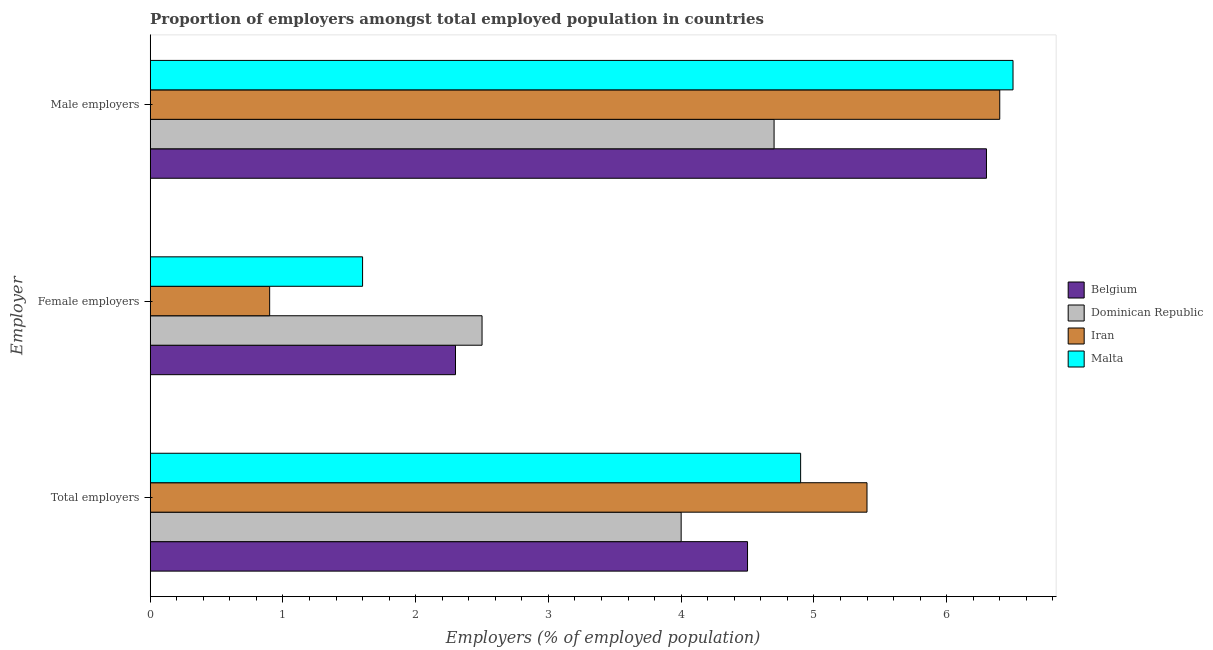How many different coloured bars are there?
Make the answer very short. 4. Are the number of bars on each tick of the Y-axis equal?
Offer a very short reply. Yes. How many bars are there on the 3rd tick from the top?
Offer a terse response. 4. What is the label of the 2nd group of bars from the top?
Keep it short and to the point. Female employers. What is the percentage of total employers in Belgium?
Provide a short and direct response. 4.5. Across all countries, what is the maximum percentage of female employers?
Your answer should be compact. 2.5. Across all countries, what is the minimum percentage of male employers?
Your answer should be compact. 4.7. In which country was the percentage of total employers maximum?
Your answer should be compact. Iran. In which country was the percentage of female employers minimum?
Give a very brief answer. Iran. What is the total percentage of male employers in the graph?
Make the answer very short. 23.9. What is the difference between the percentage of male employers in Dominican Republic and that in Iran?
Offer a very short reply. -1.7. What is the difference between the percentage of total employers in Malta and the percentage of male employers in Dominican Republic?
Your response must be concise. 0.2. What is the average percentage of female employers per country?
Your answer should be compact. 1.82. What is the difference between the percentage of female employers and percentage of total employers in Belgium?
Your answer should be very brief. -2.2. What is the ratio of the percentage of total employers in Dominican Republic to that in Belgium?
Keep it short and to the point. 0.89. Is the percentage of total employers in Dominican Republic less than that in Iran?
Offer a terse response. Yes. Is the difference between the percentage of female employers in Dominican Republic and Iran greater than the difference between the percentage of total employers in Dominican Republic and Iran?
Keep it short and to the point. Yes. What is the difference between the highest and the second highest percentage of female employers?
Offer a very short reply. 0.2. What is the difference between the highest and the lowest percentage of total employers?
Your response must be concise. 1.4. What does the 2nd bar from the top in Male employers represents?
Your response must be concise. Iran. What does the 3rd bar from the bottom in Female employers represents?
Your answer should be very brief. Iran. Is it the case that in every country, the sum of the percentage of total employers and percentage of female employers is greater than the percentage of male employers?
Your response must be concise. No. What is the difference between two consecutive major ticks on the X-axis?
Keep it short and to the point. 1. Does the graph contain any zero values?
Make the answer very short. No. Does the graph contain grids?
Give a very brief answer. No. What is the title of the graph?
Your answer should be compact. Proportion of employers amongst total employed population in countries. What is the label or title of the X-axis?
Make the answer very short. Employers (% of employed population). What is the label or title of the Y-axis?
Provide a succinct answer. Employer. What is the Employers (% of employed population) in Dominican Republic in Total employers?
Offer a terse response. 4. What is the Employers (% of employed population) of Iran in Total employers?
Your answer should be very brief. 5.4. What is the Employers (% of employed population) in Malta in Total employers?
Provide a short and direct response. 4.9. What is the Employers (% of employed population) of Belgium in Female employers?
Give a very brief answer. 2.3. What is the Employers (% of employed population) in Iran in Female employers?
Your response must be concise. 0.9. What is the Employers (% of employed population) of Malta in Female employers?
Make the answer very short. 1.6. What is the Employers (% of employed population) of Belgium in Male employers?
Provide a short and direct response. 6.3. What is the Employers (% of employed population) of Dominican Republic in Male employers?
Your answer should be compact. 4.7. What is the Employers (% of employed population) in Iran in Male employers?
Ensure brevity in your answer.  6.4. What is the Employers (% of employed population) in Malta in Male employers?
Provide a short and direct response. 6.5. Across all Employer, what is the maximum Employers (% of employed population) of Belgium?
Your answer should be very brief. 6.3. Across all Employer, what is the maximum Employers (% of employed population) in Dominican Republic?
Provide a short and direct response. 4.7. Across all Employer, what is the maximum Employers (% of employed population) in Iran?
Provide a succinct answer. 6.4. Across all Employer, what is the maximum Employers (% of employed population) in Malta?
Provide a succinct answer. 6.5. Across all Employer, what is the minimum Employers (% of employed population) in Belgium?
Provide a short and direct response. 2.3. Across all Employer, what is the minimum Employers (% of employed population) in Iran?
Your response must be concise. 0.9. Across all Employer, what is the minimum Employers (% of employed population) in Malta?
Give a very brief answer. 1.6. What is the total Employers (% of employed population) of Belgium in the graph?
Keep it short and to the point. 13.1. What is the total Employers (% of employed population) of Dominican Republic in the graph?
Your answer should be compact. 11.2. What is the total Employers (% of employed population) of Iran in the graph?
Your answer should be very brief. 12.7. What is the difference between the Employers (% of employed population) of Belgium in Total employers and that in Female employers?
Your answer should be compact. 2.2. What is the difference between the Employers (% of employed population) in Malta in Total employers and that in Female employers?
Offer a very short reply. 3.3. What is the difference between the Employers (% of employed population) in Belgium in Total employers and that in Male employers?
Offer a terse response. -1.8. What is the difference between the Employers (% of employed population) in Malta in Total employers and that in Male employers?
Your answer should be compact. -1.6. What is the difference between the Employers (% of employed population) of Belgium in Female employers and that in Male employers?
Provide a succinct answer. -4. What is the difference between the Employers (% of employed population) in Dominican Republic in Female employers and that in Male employers?
Ensure brevity in your answer.  -2.2. What is the difference between the Employers (% of employed population) of Iran in Female employers and that in Male employers?
Ensure brevity in your answer.  -5.5. What is the difference between the Employers (% of employed population) in Belgium in Total employers and the Employers (% of employed population) in Dominican Republic in Female employers?
Give a very brief answer. 2. What is the difference between the Employers (% of employed population) in Belgium in Total employers and the Employers (% of employed population) in Malta in Female employers?
Offer a very short reply. 2.9. What is the difference between the Employers (% of employed population) of Dominican Republic in Total employers and the Employers (% of employed population) of Malta in Female employers?
Keep it short and to the point. 2.4. What is the difference between the Employers (% of employed population) of Dominican Republic in Total employers and the Employers (% of employed population) of Iran in Male employers?
Provide a succinct answer. -2.4. What is the difference between the Employers (% of employed population) of Dominican Republic in Total employers and the Employers (% of employed population) of Malta in Male employers?
Offer a terse response. -2.5. What is the difference between the Employers (% of employed population) of Iran in Total employers and the Employers (% of employed population) of Malta in Male employers?
Ensure brevity in your answer.  -1.1. What is the difference between the Employers (% of employed population) of Belgium in Female employers and the Employers (% of employed population) of Iran in Male employers?
Your response must be concise. -4.1. What is the difference between the Employers (% of employed population) in Dominican Republic in Female employers and the Employers (% of employed population) in Iran in Male employers?
Offer a terse response. -3.9. What is the difference between the Employers (% of employed population) in Iran in Female employers and the Employers (% of employed population) in Malta in Male employers?
Make the answer very short. -5.6. What is the average Employers (% of employed population) in Belgium per Employer?
Offer a very short reply. 4.37. What is the average Employers (% of employed population) of Dominican Republic per Employer?
Offer a very short reply. 3.73. What is the average Employers (% of employed population) of Iran per Employer?
Offer a very short reply. 4.23. What is the average Employers (% of employed population) in Malta per Employer?
Offer a terse response. 4.33. What is the difference between the Employers (% of employed population) in Belgium and Employers (% of employed population) in Dominican Republic in Total employers?
Make the answer very short. 0.5. What is the difference between the Employers (% of employed population) in Belgium and Employers (% of employed population) in Iran in Total employers?
Provide a short and direct response. -0.9. What is the difference between the Employers (% of employed population) of Iran and Employers (% of employed population) of Malta in Total employers?
Ensure brevity in your answer.  0.5. What is the difference between the Employers (% of employed population) in Belgium and Employers (% of employed population) in Dominican Republic in Female employers?
Make the answer very short. -0.2. What is the difference between the Employers (% of employed population) of Belgium and Employers (% of employed population) of Iran in Female employers?
Give a very brief answer. 1.4. What is the difference between the Employers (% of employed population) in Dominican Republic and Employers (% of employed population) in Iran in Female employers?
Your answer should be compact. 1.6. What is the difference between the Employers (% of employed population) in Dominican Republic and Employers (% of employed population) in Malta in Female employers?
Provide a succinct answer. 0.9. What is the difference between the Employers (% of employed population) in Iran and Employers (% of employed population) in Malta in Female employers?
Your answer should be very brief. -0.7. What is the difference between the Employers (% of employed population) of Belgium and Employers (% of employed population) of Dominican Republic in Male employers?
Your response must be concise. 1.6. What is the difference between the Employers (% of employed population) of Belgium and Employers (% of employed population) of Iran in Male employers?
Offer a very short reply. -0.1. What is the difference between the Employers (% of employed population) of Belgium and Employers (% of employed population) of Malta in Male employers?
Make the answer very short. -0.2. What is the difference between the Employers (% of employed population) of Dominican Republic and Employers (% of employed population) of Malta in Male employers?
Your response must be concise. -1.8. What is the ratio of the Employers (% of employed population) in Belgium in Total employers to that in Female employers?
Offer a terse response. 1.96. What is the ratio of the Employers (% of employed population) of Dominican Republic in Total employers to that in Female employers?
Make the answer very short. 1.6. What is the ratio of the Employers (% of employed population) of Iran in Total employers to that in Female employers?
Your answer should be compact. 6. What is the ratio of the Employers (% of employed population) of Malta in Total employers to that in Female employers?
Make the answer very short. 3.06. What is the ratio of the Employers (% of employed population) of Belgium in Total employers to that in Male employers?
Provide a succinct answer. 0.71. What is the ratio of the Employers (% of employed population) of Dominican Republic in Total employers to that in Male employers?
Your answer should be compact. 0.85. What is the ratio of the Employers (% of employed population) in Iran in Total employers to that in Male employers?
Keep it short and to the point. 0.84. What is the ratio of the Employers (% of employed population) in Malta in Total employers to that in Male employers?
Your answer should be very brief. 0.75. What is the ratio of the Employers (% of employed population) of Belgium in Female employers to that in Male employers?
Offer a terse response. 0.37. What is the ratio of the Employers (% of employed population) in Dominican Republic in Female employers to that in Male employers?
Your answer should be very brief. 0.53. What is the ratio of the Employers (% of employed population) of Iran in Female employers to that in Male employers?
Your response must be concise. 0.14. What is the ratio of the Employers (% of employed population) of Malta in Female employers to that in Male employers?
Provide a succinct answer. 0.25. What is the difference between the highest and the second highest Employers (% of employed population) of Belgium?
Make the answer very short. 1.8. What is the difference between the highest and the second highest Employers (% of employed population) in Dominican Republic?
Offer a very short reply. 0.7. What is the difference between the highest and the second highest Employers (% of employed population) of Iran?
Your answer should be very brief. 1. What is the difference between the highest and the lowest Employers (% of employed population) of Belgium?
Give a very brief answer. 4. What is the difference between the highest and the lowest Employers (% of employed population) in Malta?
Offer a terse response. 4.9. 